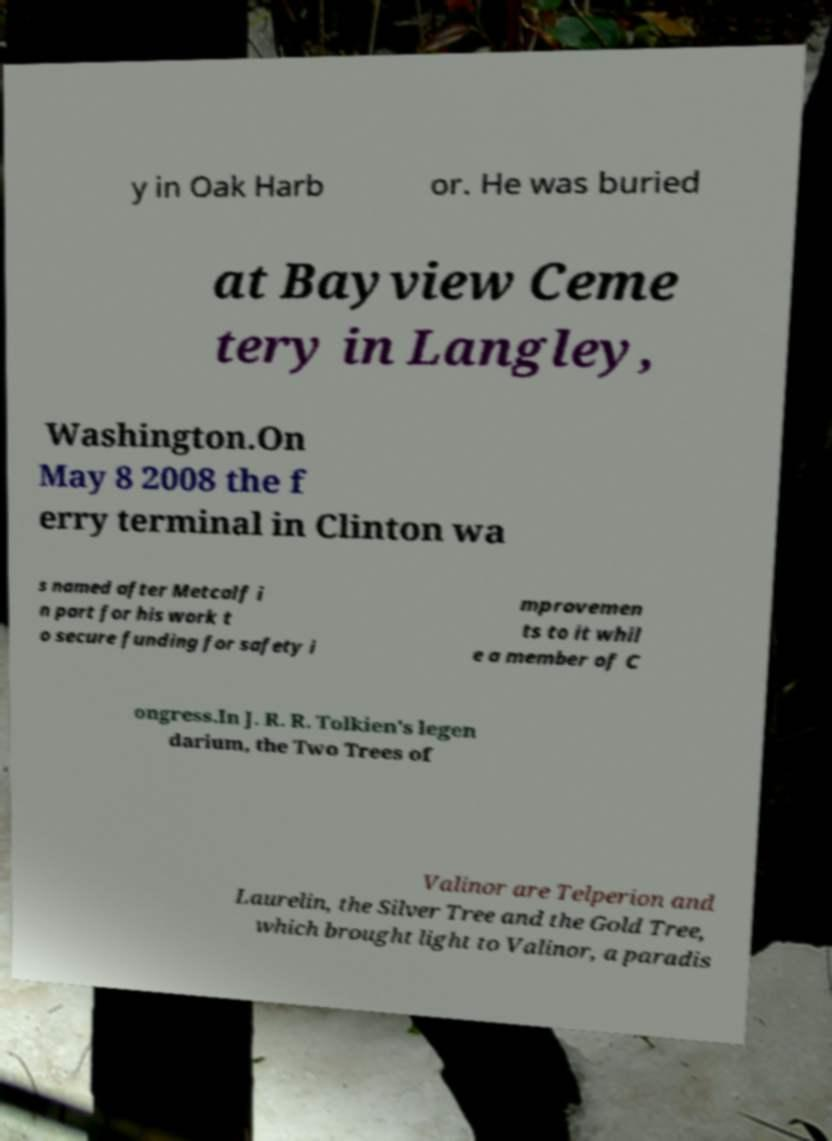Could you extract and type out the text from this image? y in Oak Harb or. He was buried at Bayview Ceme tery in Langley, Washington.On May 8 2008 the f erry terminal in Clinton wa s named after Metcalf i n part for his work t o secure funding for safety i mprovemen ts to it whil e a member of C ongress.In J. R. R. Tolkien's legen darium, the Two Trees of Valinor are Telperion and Laurelin, the Silver Tree and the Gold Tree, which brought light to Valinor, a paradis 